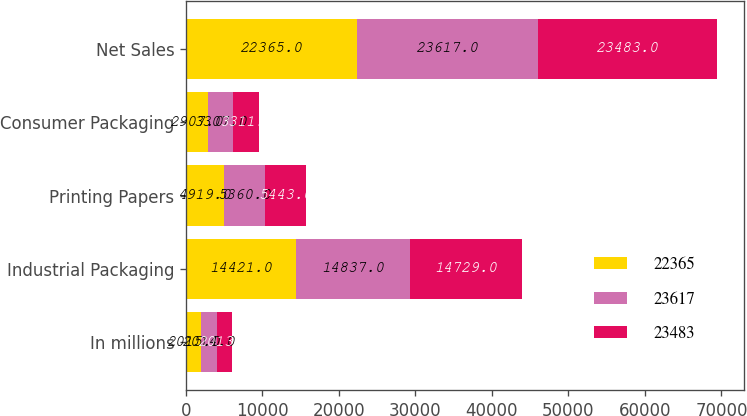<chart> <loc_0><loc_0><loc_500><loc_500><stacked_bar_chart><ecel><fcel>In millions<fcel>Industrial Packaging<fcel>Printing Papers<fcel>Consumer Packaging<fcel>Net Sales<nl><fcel>22365<fcel>2015<fcel>14421<fcel>4919<fcel>2907<fcel>22365<nl><fcel>23617<fcel>2014<fcel>14837<fcel>5360<fcel>3307<fcel>23617<nl><fcel>23483<fcel>2013<fcel>14729<fcel>5443<fcel>3311<fcel>23483<nl></chart> 